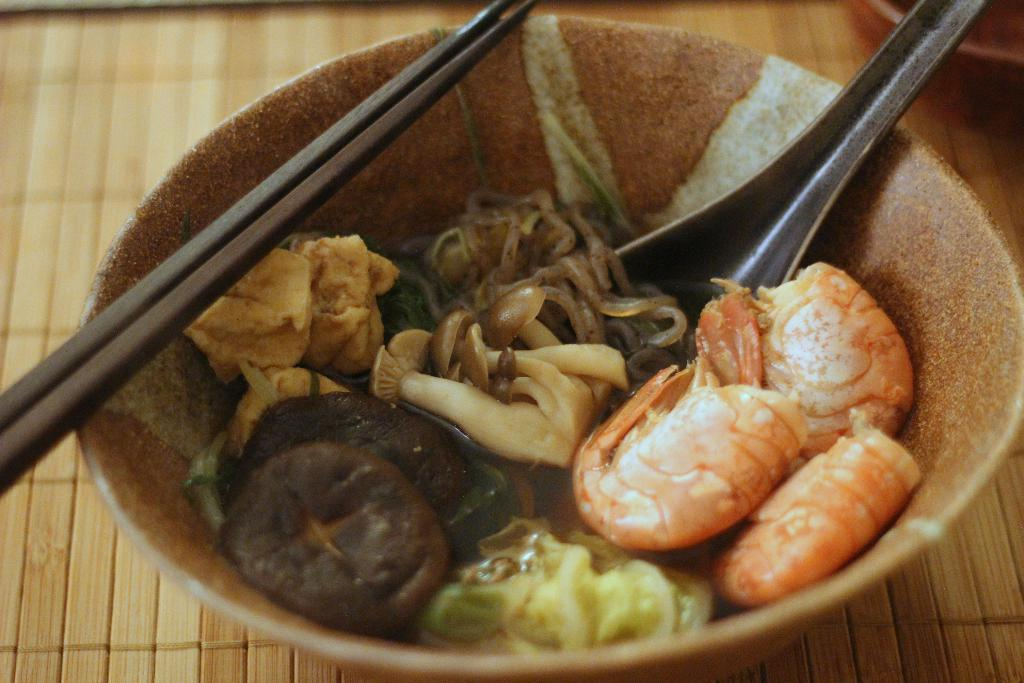What is in the bowl that is visible in the image? There is a bowl with food in the image. What utensil is present in the image? A spoon is present in the image. What other utensil can be seen in the image? Chopsticks are visible in the image. What type of arch can be seen in the background of the image? There is no arch present in the image; it only features a bowl with food, a spoon, and chopsticks. 